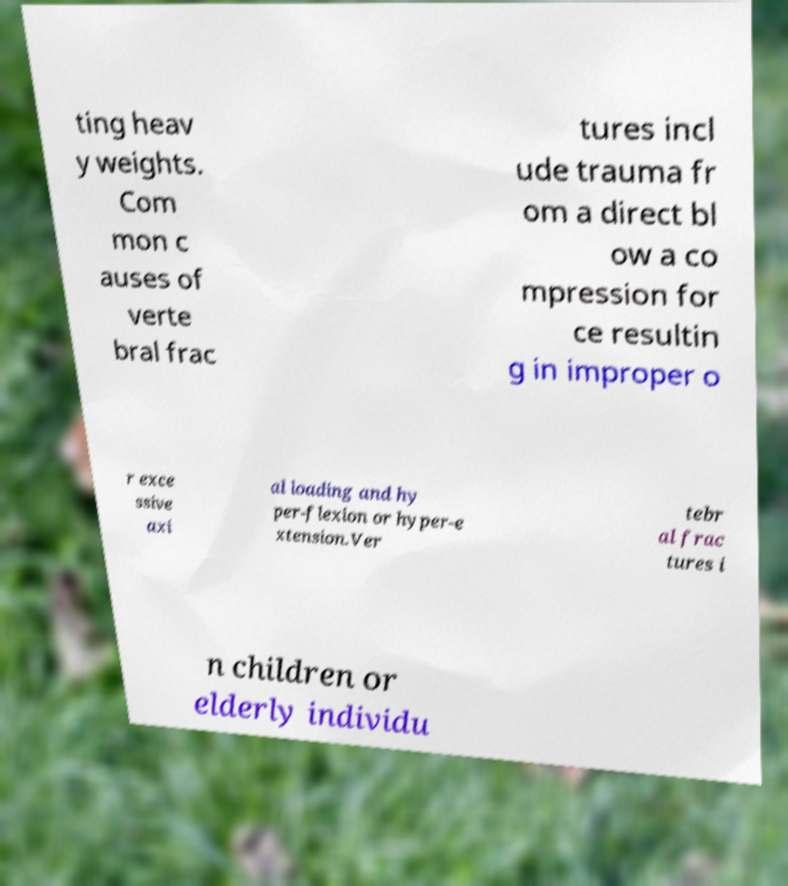I need the written content from this picture converted into text. Can you do that? ting heav y weights. Com mon c auses of verte bral frac tures incl ude trauma fr om a direct bl ow a co mpression for ce resultin g in improper o r exce ssive axi al loading and hy per-flexion or hyper-e xtension.Ver tebr al frac tures i n children or elderly individu 